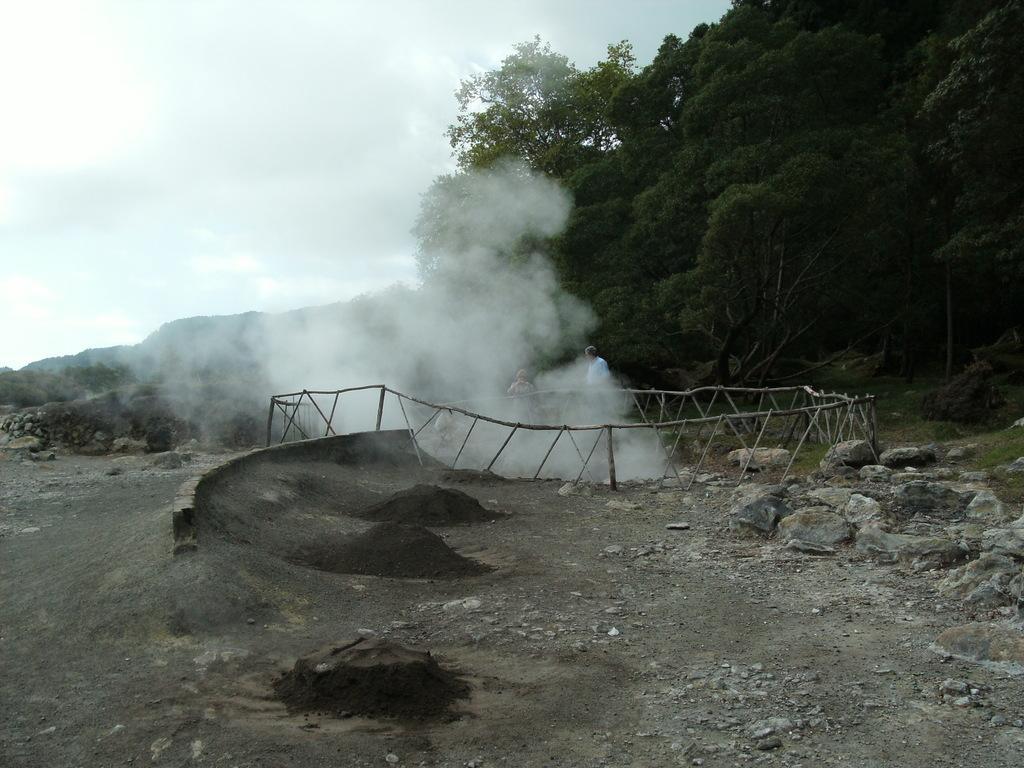In one or two sentences, can you explain what this image depicts? In this image there is the sky towards the top of the image, there are trees towards the right of the image, there is a fencing, there is a man and a woman standing, there is smoke, there are rocks on the ground, there are stones on the ground, there is mud on the ground. 